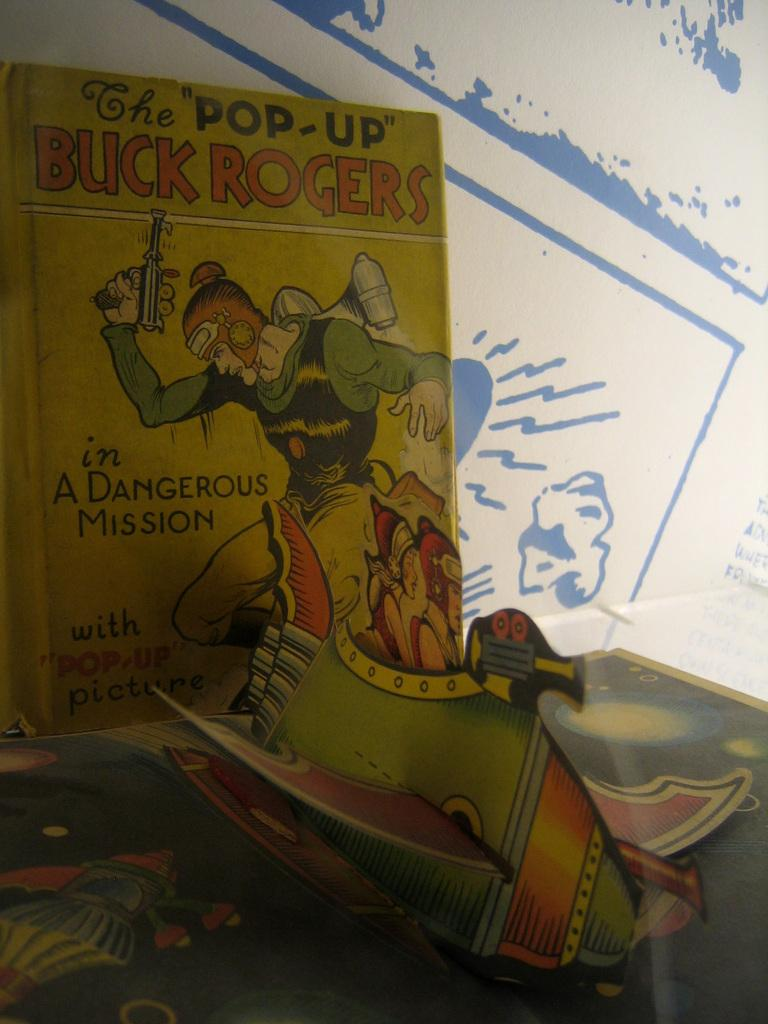<image>
Create a compact narrative representing the image presented. A pop-up book called The Pop-Up Buck Rogers. 